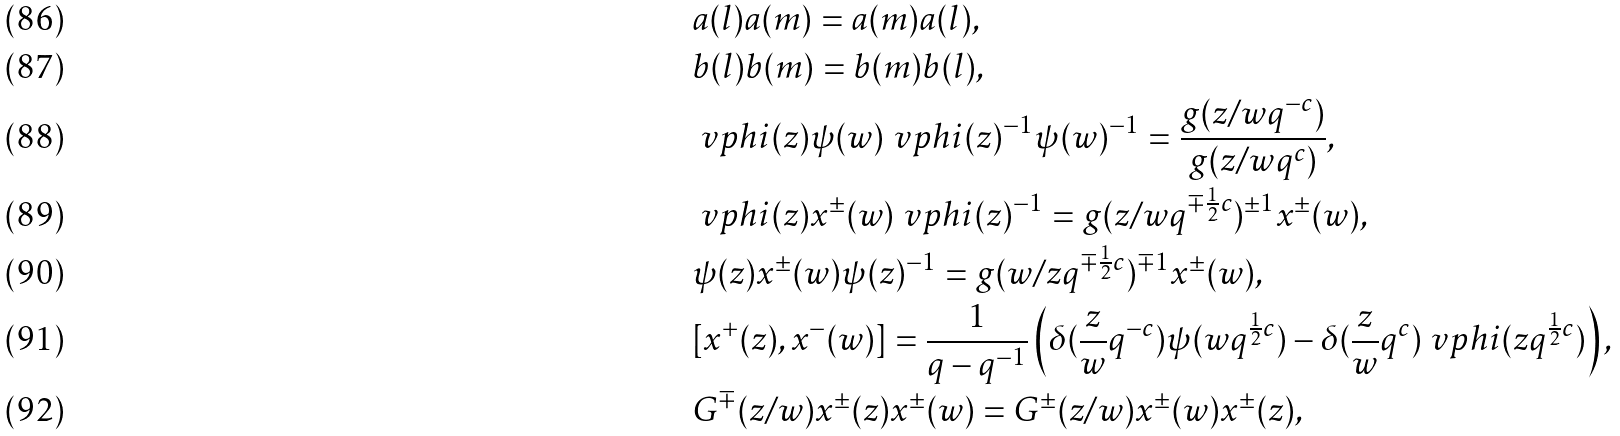<formula> <loc_0><loc_0><loc_500><loc_500>& a ( l ) a ( m ) = a ( m ) a ( l ) , \\ & b ( l ) b ( m ) = b ( m ) b ( l ) , \\ & \ v p h i ( z ) \psi ( w ) \ v p h i ( z ) ^ { - 1 } \psi ( w ) ^ { - 1 } = \frac { g ( z / w q ^ { - c } ) } { g ( z / w q ^ { c } ) } , \\ & \ v p h i ( z ) x ^ { \pm } ( w ) \ v p h i ( z ) ^ { - 1 } = g ( z / w q ^ { \mp \frac { 1 } { 2 } c } ) ^ { \pm 1 } x ^ { \pm } ( w ) , \\ & \psi ( z ) x ^ { \pm } ( w ) \psi ( z ) ^ { - 1 } = g ( w / z q ^ { \mp \frac { 1 } { 2 } c } ) ^ { \mp 1 } x ^ { \pm } ( w ) , \\ & [ x ^ { + } ( z ) , x ^ { - } ( w ) ] = \frac { 1 } { q - q ^ { - 1 } } \left ( \delta ( \frac { z } { w } q ^ { - c } ) \psi ( w q ^ { \frac { 1 } { 2 } c } ) - \delta ( \frac { z } { w } q ^ { c } ) \ v p h i ( z q ^ { \frac { 1 } { 2 } c } ) \right ) , \\ & G ^ { \mp } ( z / w ) x ^ { \pm } ( z ) x ^ { \pm } ( w ) = G ^ { \pm } ( z / w ) x ^ { \pm } ( w ) x ^ { \pm } ( z ) ,</formula> 